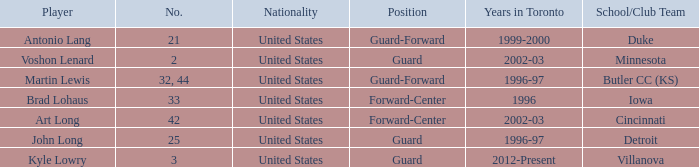Help me parse the entirety of this table. {'header': ['Player', 'No.', 'Nationality', 'Position', 'Years in Toronto', 'School/Club Team'], 'rows': [['Antonio Lang', '21', 'United States', 'Guard-Forward', '1999-2000', 'Duke'], ['Voshon Lenard', '2', 'United States', 'Guard', '2002-03', 'Minnesota'], ['Martin Lewis', '32, 44', 'United States', 'Guard-Forward', '1996-97', 'Butler CC (KS)'], ['Brad Lohaus', '33', 'United States', 'Forward-Center', '1996', 'Iowa'], ['Art Long', '42', 'United States', 'Forward-Center', '2002-03', 'Cincinnati'], ['John Long', '25', 'United States', 'Guard', '1996-97', 'Detroit'], ['Kyle Lowry', '3', 'United States', 'Guard', '2012-Present', 'Villanova']]} Who is the player that wears number 42? Art Long. 